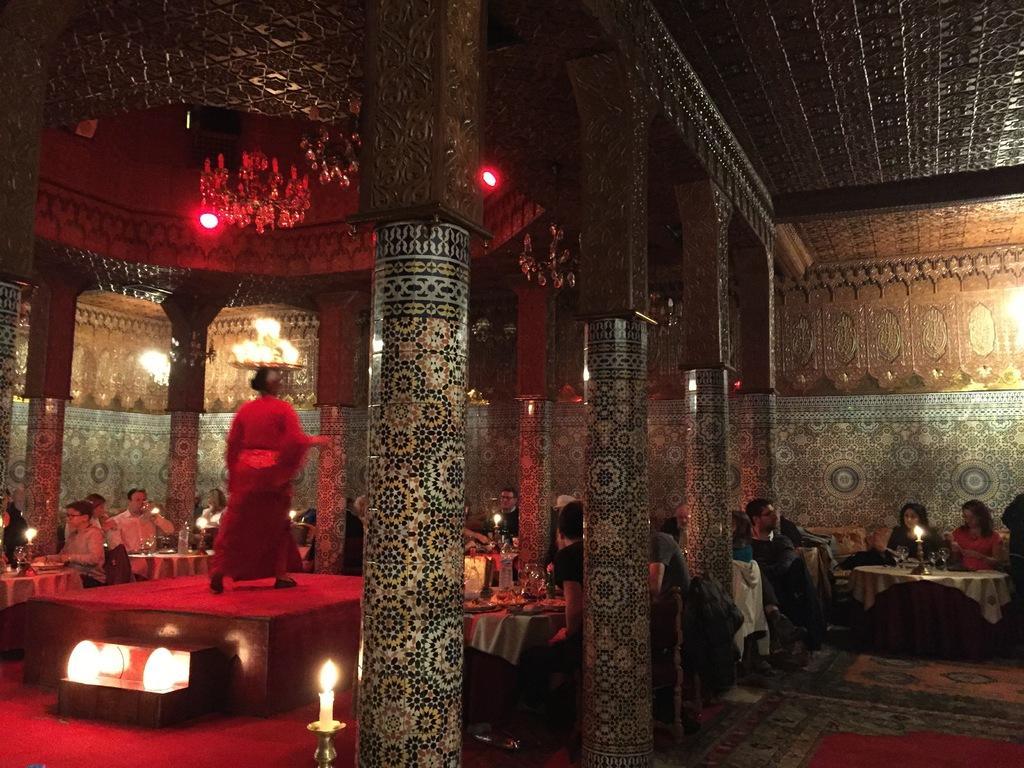In one or two sentences, can you explain what this image depicts? In this picture there are people those who are sitting around the table and there is a lady at the left side of the image on the stage, the walls and ceiling of this place are decorated as this is the view of the hotel. 